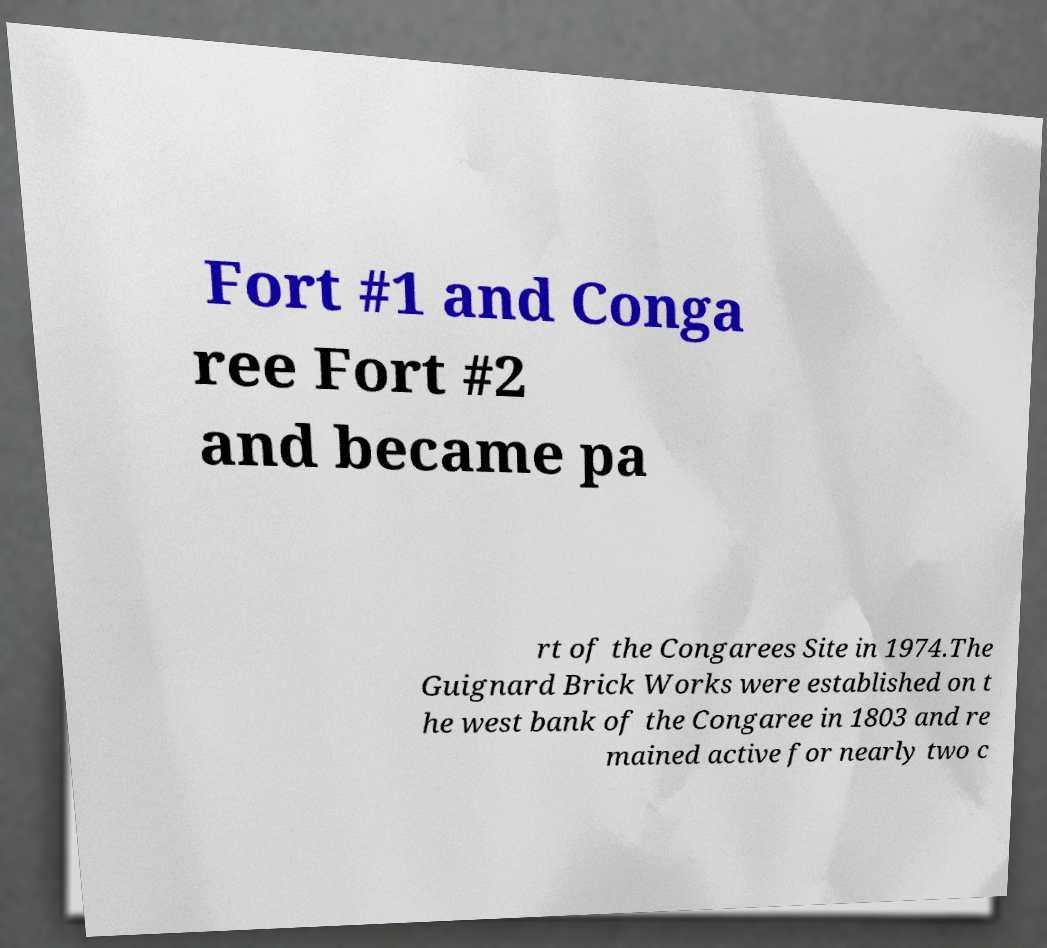Can you accurately transcribe the text from the provided image for me? Fort #1 and Conga ree Fort #2 and became pa rt of the Congarees Site in 1974.The Guignard Brick Works were established on t he west bank of the Congaree in 1803 and re mained active for nearly two c 